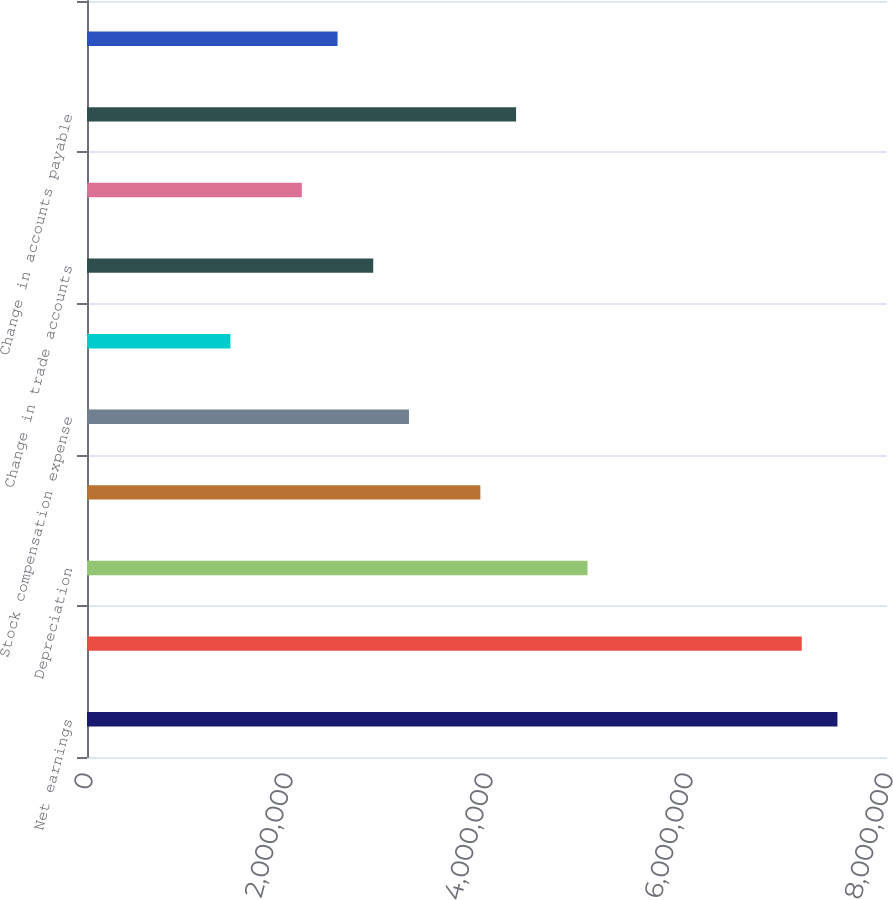<chart> <loc_0><loc_0><loc_500><loc_500><bar_chart><fcel>Net earnings<fcel>Net earnings from continuing<fcel>Depreciation<fcel>Amortization<fcel>Stock compensation expense<fcel>Change in deferred income<fcel>Change in trade accounts<fcel>Change in inventories<fcel>Change in accounts payable<fcel>Change in prepaid expenses and<nl><fcel>7.50455e+06<fcel>7.14746e+06<fcel>5.00492e+06<fcel>3.93365e+06<fcel>3.21947e+06<fcel>1.43402e+06<fcel>2.86238e+06<fcel>2.1482e+06<fcel>4.29074e+06<fcel>2.50529e+06<nl></chart> 